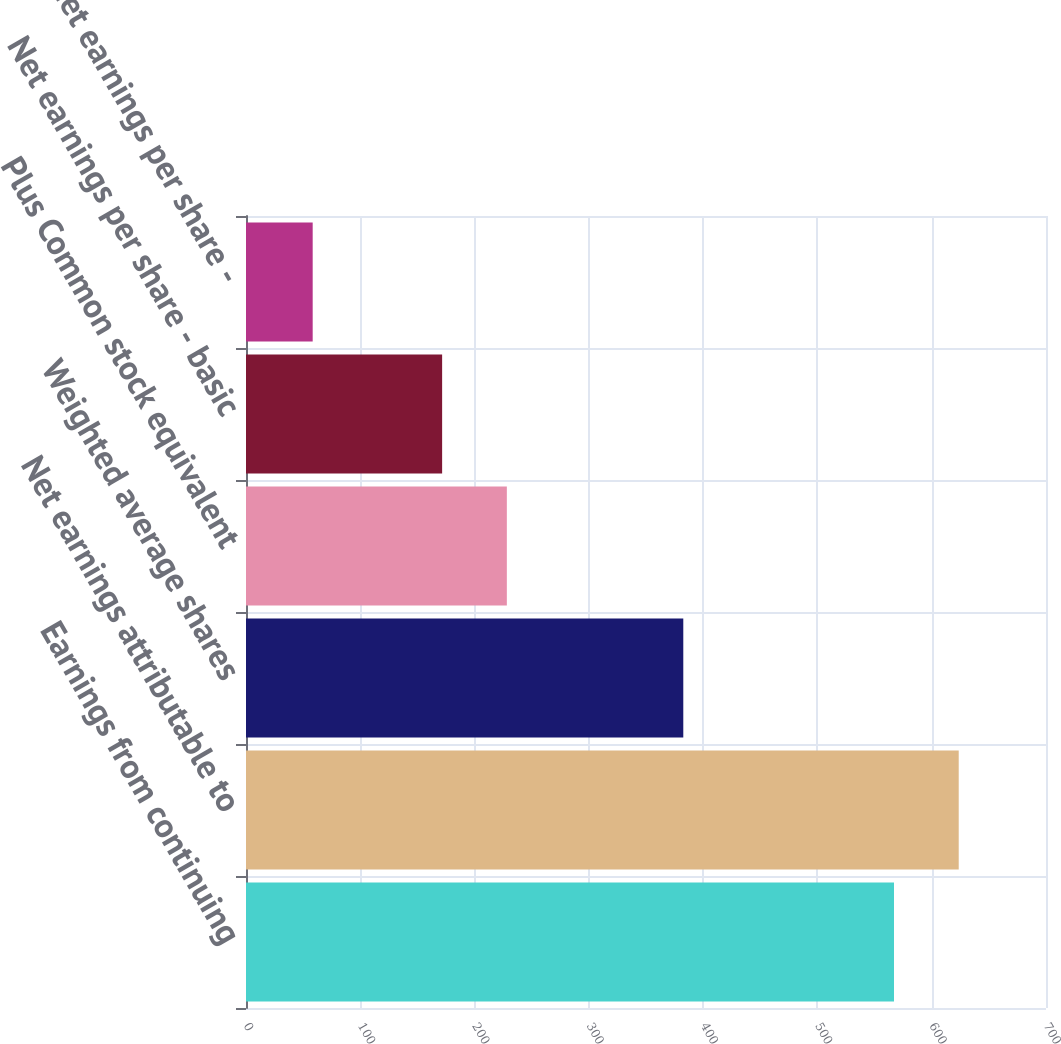<chart> <loc_0><loc_0><loc_500><loc_500><bar_chart><fcel>Earnings from continuing<fcel>Net earnings attributable to<fcel>Weighted average shares<fcel>Plus Common stock equivalent<fcel>Net earnings per share - basic<fcel>Net earnings per share -<nl><fcel>567<fcel>623.63<fcel>382.63<fcel>228.24<fcel>171.61<fcel>58.35<nl></chart> 